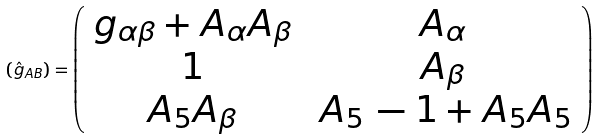Convert formula to latex. <formula><loc_0><loc_0><loc_500><loc_500>\left ( \hat { g } _ { A B } \right ) = \left ( \begin{array} { c c } g _ { \alpha \beta } + A _ { \alpha } A _ { \beta } \, & \, A _ { \alpha } \, \\ 1 \, & \, A _ { \beta } \, \\ A _ { 5 } A _ { \beta } \, & \, A _ { 5 } \, - 1 + A _ { 5 } A _ { 5 } \end{array} \right )</formula> 